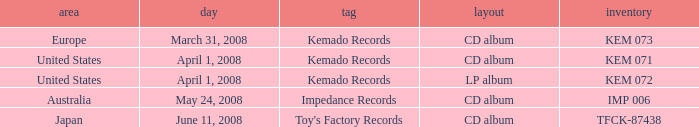Which Region has a Catalog of kem 072? United States. 